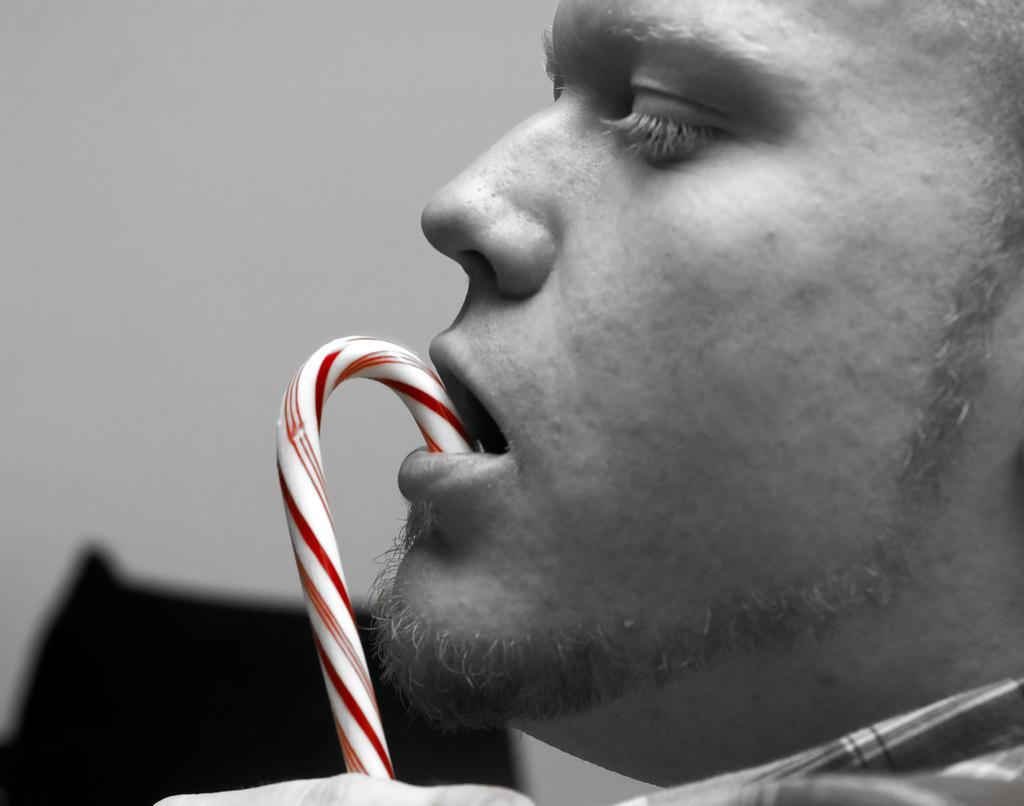Please provide a concise description of this image. In the front of the image I can see a person's face and an object. In the background of the image it is blurry.  